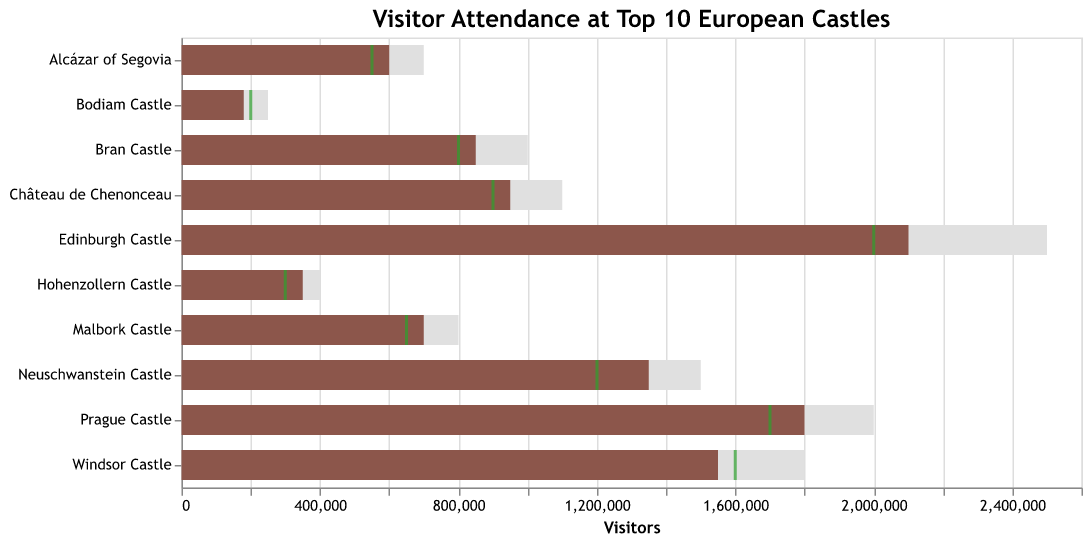What is the title of the chart? The title is located at the top of the chart and is the first element of the chart that provides context to what the data represents.
Answer: Visitor Attendance at Top 10 European Castles How many castles had actual visitors exceeding their target visitors? To find the castles where actual visitors exceeded target visitors, compare the bar length (actual) and tick mark (target) for each castle.
Answer: 7 Which castle had the highest number of actual visitors? This can be determined by identifying the longest colored bar representing actual visitors.
Answer: Edinburgh Castle What is the difference between the actual and target visitors for Prague Castle? By examining the position of the bar (actual visitors) and the tick (target visitors) for Prague Castle, you can subtract the number of target visitors from the actual visitors (1800000 - 1700000).
Answer: 100,000 Did any castle reach its maximum capacity? If yes, which one(s)? To determine if any castle reached its maximum capacity, compare the length of the actual visitors bars against the maximum capacity bars.
Answer: No How many visitors short was Bodiam Castle of reaching its target? For Bodiam Castle, subtract the actual visitors (180,000) from the target visitors (200,000).
Answer: 20,000 Which castle has the smallest difference between actual visitors and maximum capacity? Calculate the difference for each castle and identify the smallest one. Neuschwanstein Castle and Château de Chenonceau both show actual visitors very close to maximum capacity. However, Malbork Castle has a smaller absolute difference (800,000 - 700,000).
Answer: Malbork Castle What percentage of the target did Windsor Castle achieve? Divide the actual visitors of Windsor Castle (1,550,000) by its target visitors (1,600,000) and multiply by 100 to get the percentage.
Answer: 96.875% Rank the castles based on their actual visitors. Which castle is third on the list? To rank the castles, order the bars representing actual visitors from longest to shortest. The third castle on the list by visual inspection is Windsor Castle.
Answer: Windsor Castle 